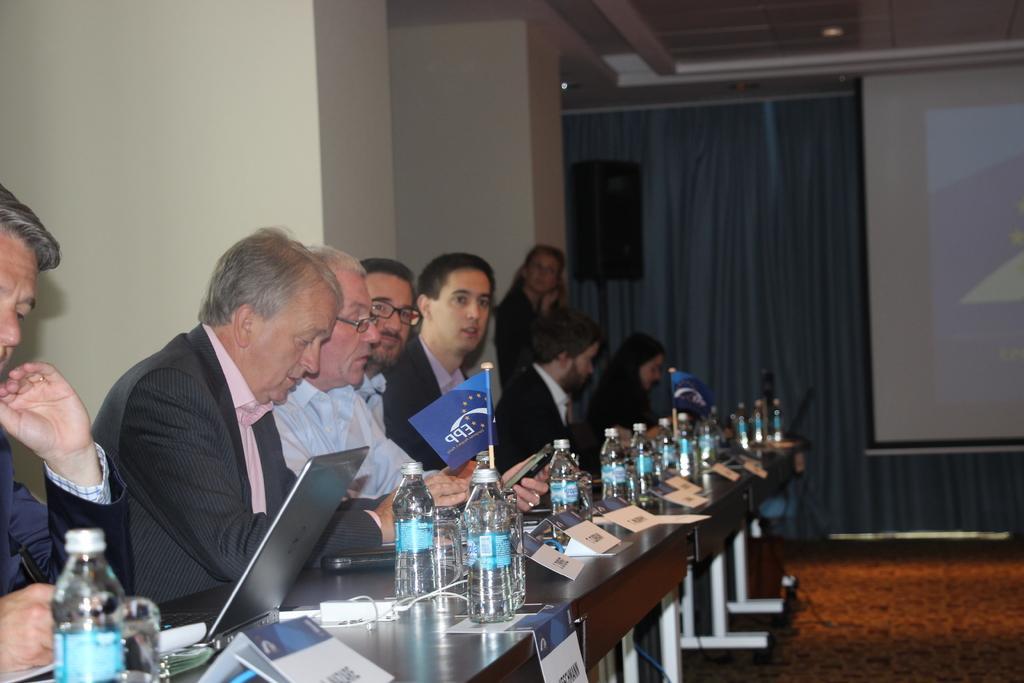In one or two sentences, can you explain what this image depicts? In this picture we can see some persons are sitting on the chairs. This is table. On the table there are bottles, and a laptop. This is floor. On the background we can see a screen and this is curtain. 